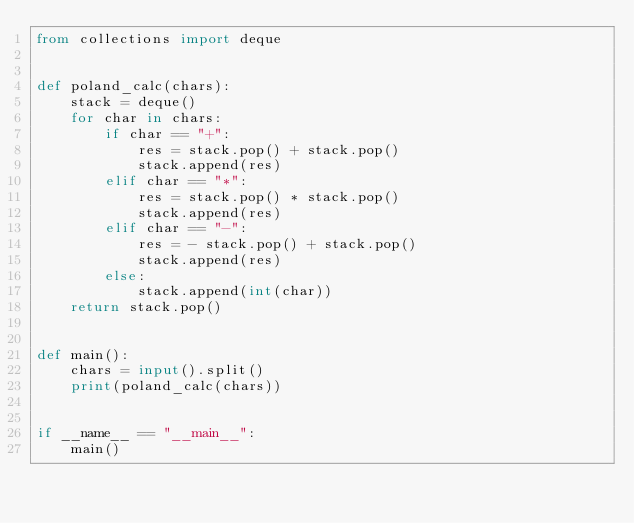<code> <loc_0><loc_0><loc_500><loc_500><_Python_>from collections import deque


def poland_calc(chars):
    stack = deque()
    for char in chars:
        if char == "+":
            res = stack.pop() + stack.pop()
            stack.append(res)
        elif char == "*":
            res = stack.pop() * stack.pop()
            stack.append(res)
        elif char == "-":
            res = - stack.pop() + stack.pop()
            stack.append(res)
        else:
            stack.append(int(char))
    return stack.pop()


def main():
    chars = input().split()
    print(poland_calc(chars))


if __name__ == "__main__":
    main()

</code> 